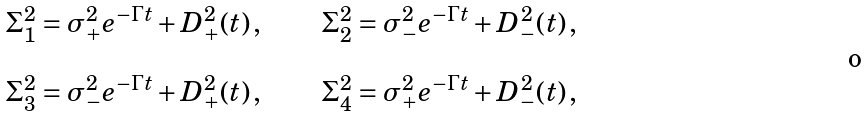<formula> <loc_0><loc_0><loc_500><loc_500>\begin{array} { l l l } \Sigma _ { 1 } ^ { 2 } = \sigma _ { + } ^ { 2 } e ^ { - \Gamma t } + D _ { + } ^ { 2 } ( t ) \, , & \quad & \Sigma _ { 2 } ^ { 2 } = \sigma _ { - } ^ { 2 } e ^ { - \Gamma t } + D _ { - } ^ { 2 } ( t ) \, , \\ \\ \Sigma _ { 3 } ^ { 2 } = \sigma _ { - } ^ { 2 } e ^ { - \Gamma t } + D _ { + } ^ { 2 } ( t ) \, , & \quad & \Sigma _ { 4 } ^ { 2 } = \sigma _ { + } ^ { 2 } e ^ { - \Gamma t } + D _ { - } ^ { 2 } ( t ) \, , \end{array}</formula> 